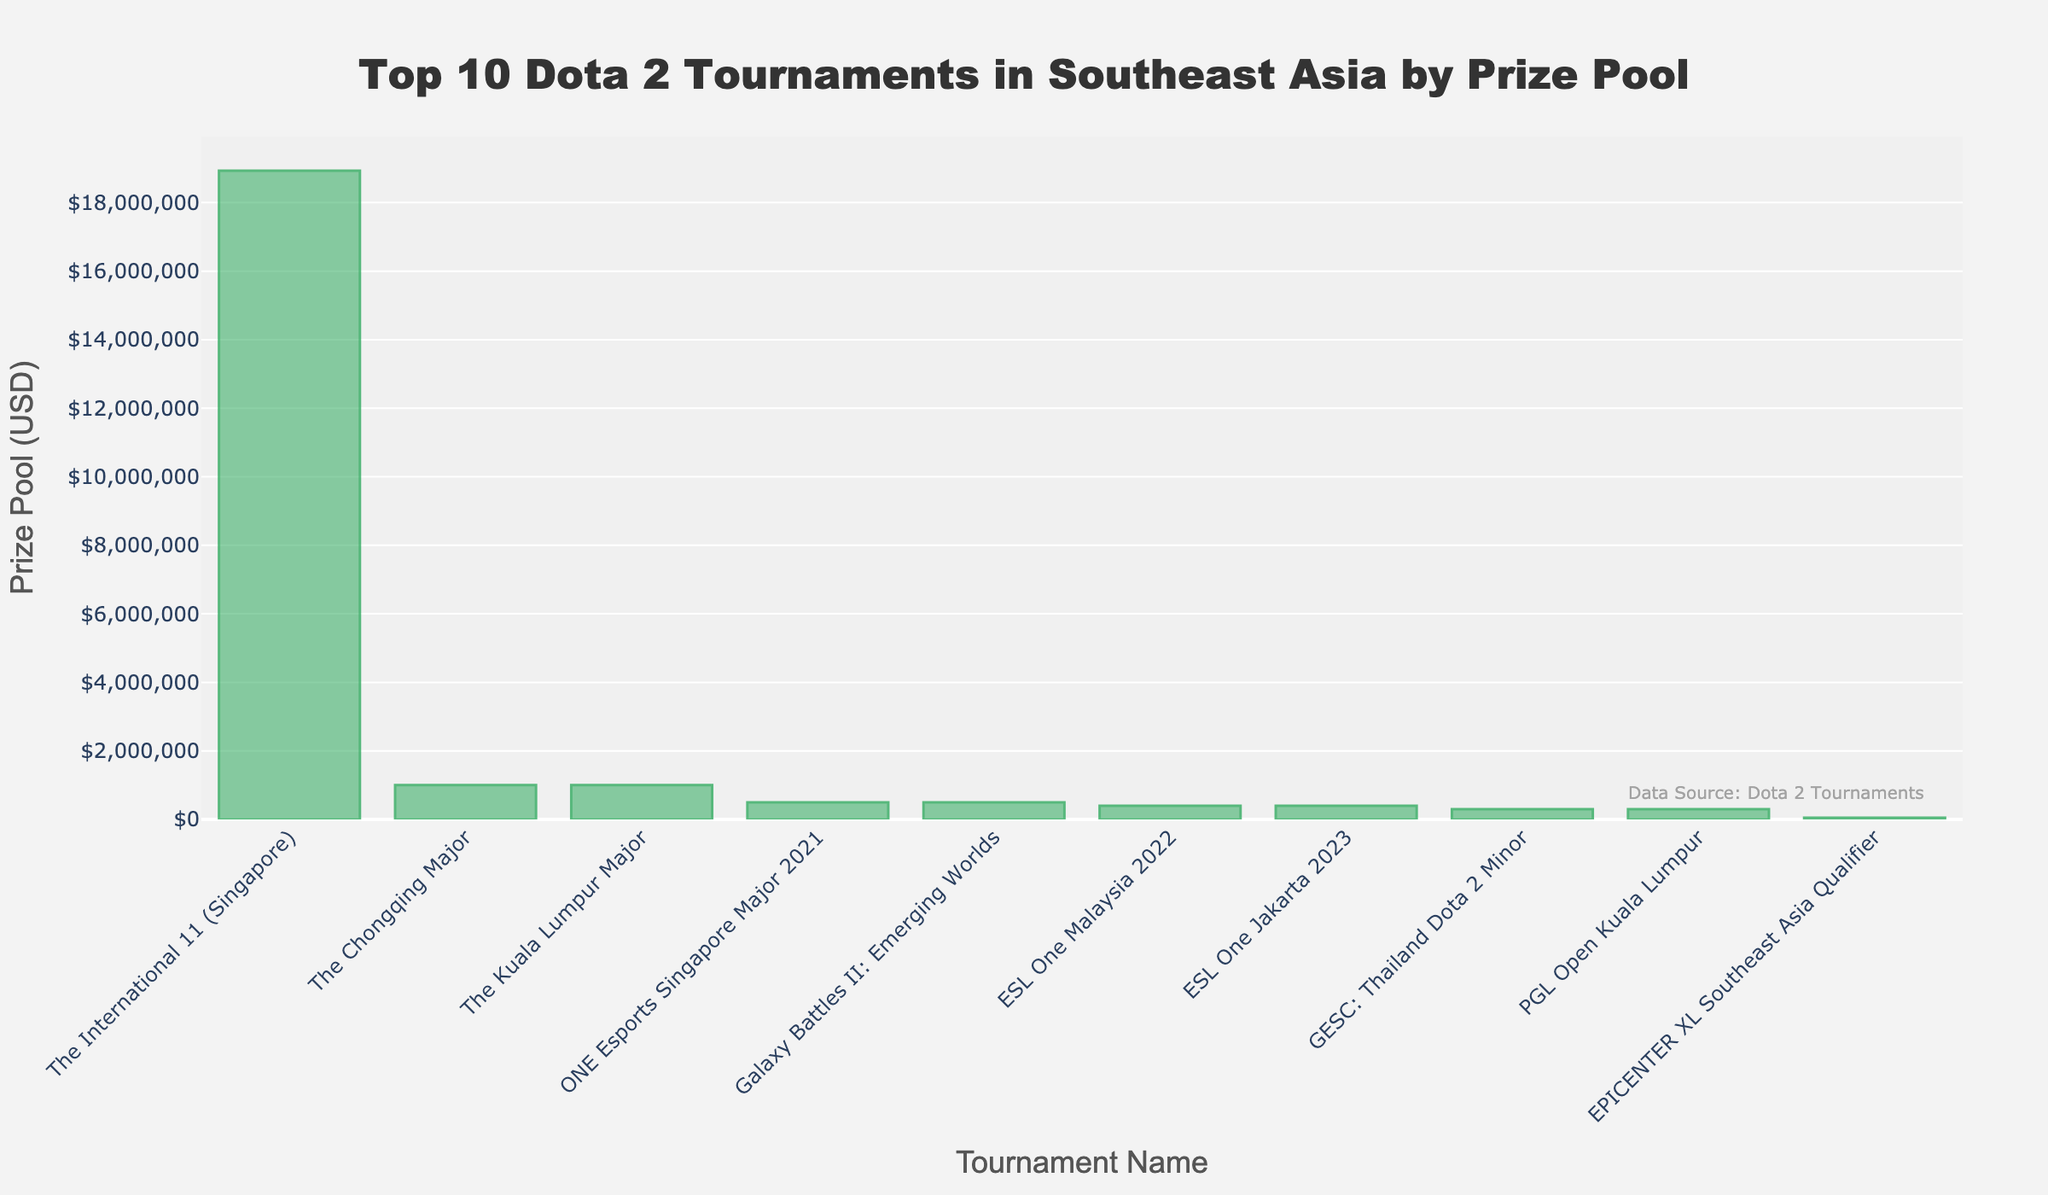Which tournament has the highest prize pool? To determine the tournament with the highest prize pool, look at the bar with the greatest height. "The International 11 (Singapore)" has the tallest bar, indicating it has the highest prize pool.
Answer: The International 11 (Singapore) How much more prize money did The Chongqing Major have compared to EPICENTER XL Southeast Asia Qualifier? Check the prize pools for "The Chongqing Major" ($1,000,000) and "EPICENTER XL Southeast Asia Qualifier" ($50,000). Subtract the prize pool of EPICENTER from The Chongqing Major: $1,000,000 - $50,000 = $950,000.
Answer: $950,000 Which tournament has the smallest prize pool? Identify the shortest bar on the chart which corresponds to the tournament with the smallest prize pool. "EPICENTER XL Southeast Asia Qualifier" has the shortest bar.
Answer: EPICENTER XL Southeast Asia Qualifier What is the total prize pool of the top 3 tournaments? The top 3 tournaments are "The International 11 (Singapore)", "The Chongqing Major", and "The Kuala Lumpur Major" with prize pools of $18,930,775, $1,000,000, and $1,000,000 respectively. Add these values: $18,930,775 + $1,000,000 + $1,000,000 = $20,930,775.
Answer: $20,930,775 Which two tournaments have identical prize pools and what is their prize value? Look for bars of the same height. "ESL One Malaysia 2022" and "ESL One Jakarta 2023" both have a prize pool of $400,000.
Answer: ESL One Malaysia 2022 and ESL One Jakarta 2023, $400,000 How does the prize pool of the ONE Esports Singapore Major 2021 compare to Galaxy Battles II: Emerging Worlds? Check the prize pools for "ONE Esports Singapore Major 2021" ($500,000) and "Galaxy Battles II: Emerging Worlds" ($500,000). Both have the same amount.
Answer: They are the same What is the average prize pool of all the tournaments shown? Add up all the prize pools and divide by the number of tournaments. The prize pools are: $18,930,775 + $500,000 + $400,000 + $1,000,000 + $300,000 + $300,000 + $400,000 + $1,000,000 + $500,000 + $50,000. Total is $23,380,775. Divide by 10 (number of tournaments): $23,380,775 / 10 = $2,338,077.50.
Answer: $2,338,077.50 